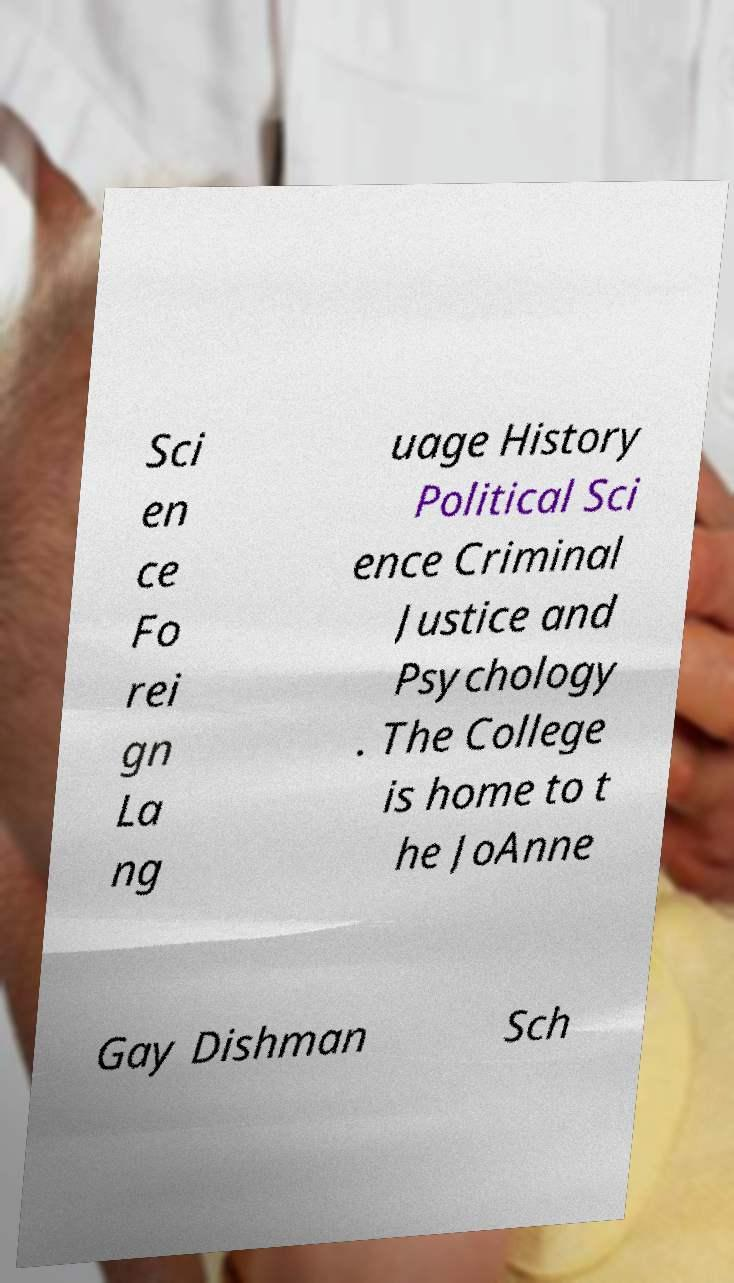What messages or text are displayed in this image? I need them in a readable, typed format. Sci en ce Fo rei gn La ng uage History Political Sci ence Criminal Justice and Psychology . The College is home to t he JoAnne Gay Dishman Sch 